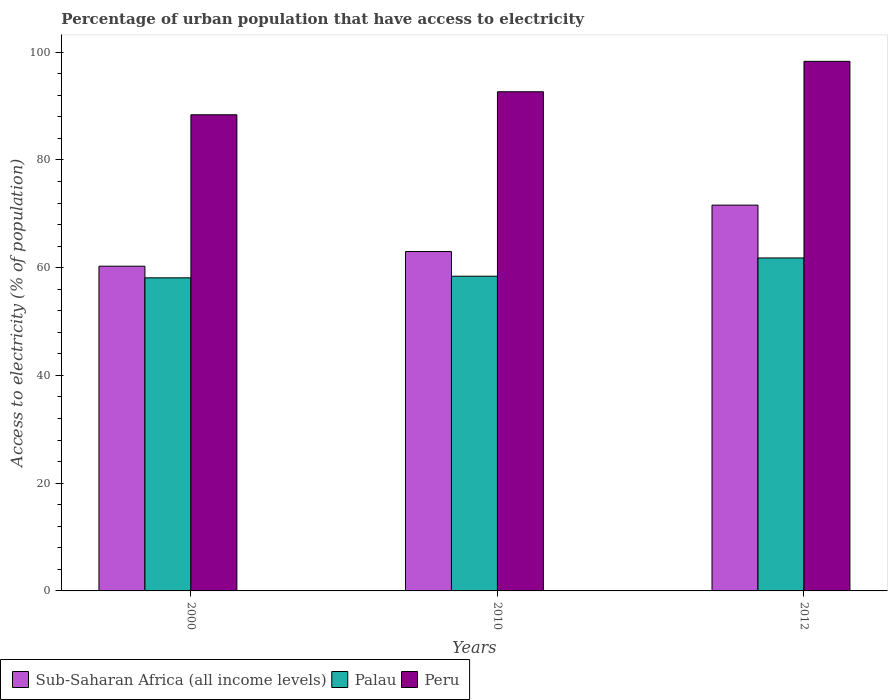How many bars are there on the 1st tick from the left?
Offer a very short reply. 3. In how many cases, is the number of bars for a given year not equal to the number of legend labels?
Provide a succinct answer. 0. What is the percentage of urban population that have access to electricity in Sub-Saharan Africa (all income levels) in 2000?
Offer a very short reply. 60.28. Across all years, what is the maximum percentage of urban population that have access to electricity in Sub-Saharan Africa (all income levels)?
Your response must be concise. 71.61. Across all years, what is the minimum percentage of urban population that have access to electricity in Peru?
Your response must be concise. 88.39. In which year was the percentage of urban population that have access to electricity in Palau maximum?
Give a very brief answer. 2012. What is the total percentage of urban population that have access to electricity in Peru in the graph?
Provide a succinct answer. 279.34. What is the difference between the percentage of urban population that have access to electricity in Peru in 2000 and that in 2012?
Provide a short and direct response. -9.91. What is the difference between the percentage of urban population that have access to electricity in Palau in 2000 and the percentage of urban population that have access to electricity in Peru in 2012?
Provide a short and direct response. -40.18. What is the average percentage of urban population that have access to electricity in Peru per year?
Ensure brevity in your answer.  93.11. In the year 2010, what is the difference between the percentage of urban population that have access to electricity in Palau and percentage of urban population that have access to electricity in Sub-Saharan Africa (all income levels)?
Make the answer very short. -4.58. What is the ratio of the percentage of urban population that have access to electricity in Peru in 2000 to that in 2010?
Make the answer very short. 0.95. Is the percentage of urban population that have access to electricity in Palau in 2000 less than that in 2010?
Make the answer very short. Yes. Is the difference between the percentage of urban population that have access to electricity in Palau in 2000 and 2010 greater than the difference between the percentage of urban population that have access to electricity in Sub-Saharan Africa (all income levels) in 2000 and 2010?
Offer a very short reply. Yes. What is the difference between the highest and the second highest percentage of urban population that have access to electricity in Sub-Saharan Africa (all income levels)?
Provide a short and direct response. 8.62. What is the difference between the highest and the lowest percentage of urban population that have access to electricity in Sub-Saharan Africa (all income levels)?
Your response must be concise. 11.33. What does the 1st bar from the left in 2012 represents?
Your response must be concise. Sub-Saharan Africa (all income levels). What does the 2nd bar from the right in 2000 represents?
Give a very brief answer. Palau. How many bars are there?
Keep it short and to the point. 9. How many years are there in the graph?
Your response must be concise. 3. What is the difference between two consecutive major ticks on the Y-axis?
Offer a terse response. 20. Are the values on the major ticks of Y-axis written in scientific E-notation?
Your answer should be very brief. No. Does the graph contain any zero values?
Your answer should be compact. No. How are the legend labels stacked?
Offer a terse response. Horizontal. What is the title of the graph?
Give a very brief answer. Percentage of urban population that have access to electricity. Does "Uzbekistan" appear as one of the legend labels in the graph?
Provide a short and direct response. No. What is the label or title of the X-axis?
Provide a succinct answer. Years. What is the label or title of the Y-axis?
Your response must be concise. Access to electricity (% of population). What is the Access to electricity (% of population) in Sub-Saharan Africa (all income levels) in 2000?
Provide a short and direct response. 60.28. What is the Access to electricity (% of population) of Palau in 2000?
Your response must be concise. 58.12. What is the Access to electricity (% of population) in Peru in 2000?
Offer a very short reply. 88.39. What is the Access to electricity (% of population) in Sub-Saharan Africa (all income levels) in 2010?
Your answer should be compact. 62.99. What is the Access to electricity (% of population) in Palau in 2010?
Your response must be concise. 58.41. What is the Access to electricity (% of population) in Peru in 2010?
Provide a short and direct response. 92.66. What is the Access to electricity (% of population) of Sub-Saharan Africa (all income levels) in 2012?
Offer a very short reply. 71.61. What is the Access to electricity (% of population) in Palau in 2012?
Provide a succinct answer. 61.8. What is the Access to electricity (% of population) in Peru in 2012?
Your response must be concise. 98.3. Across all years, what is the maximum Access to electricity (% of population) in Sub-Saharan Africa (all income levels)?
Your answer should be very brief. 71.61. Across all years, what is the maximum Access to electricity (% of population) in Palau?
Keep it short and to the point. 61.8. Across all years, what is the maximum Access to electricity (% of population) in Peru?
Your answer should be compact. 98.3. Across all years, what is the minimum Access to electricity (% of population) of Sub-Saharan Africa (all income levels)?
Provide a succinct answer. 60.28. Across all years, what is the minimum Access to electricity (% of population) in Palau?
Keep it short and to the point. 58.12. Across all years, what is the minimum Access to electricity (% of population) of Peru?
Offer a very short reply. 88.39. What is the total Access to electricity (% of population) in Sub-Saharan Africa (all income levels) in the graph?
Your answer should be very brief. 194.88. What is the total Access to electricity (% of population) of Palau in the graph?
Make the answer very short. 178.33. What is the total Access to electricity (% of population) of Peru in the graph?
Make the answer very short. 279.34. What is the difference between the Access to electricity (% of population) in Sub-Saharan Africa (all income levels) in 2000 and that in 2010?
Keep it short and to the point. -2.72. What is the difference between the Access to electricity (% of population) in Palau in 2000 and that in 2010?
Offer a terse response. -0.3. What is the difference between the Access to electricity (% of population) in Peru in 2000 and that in 2010?
Give a very brief answer. -4.27. What is the difference between the Access to electricity (% of population) in Sub-Saharan Africa (all income levels) in 2000 and that in 2012?
Keep it short and to the point. -11.33. What is the difference between the Access to electricity (% of population) of Palau in 2000 and that in 2012?
Offer a very short reply. -3.69. What is the difference between the Access to electricity (% of population) of Peru in 2000 and that in 2012?
Give a very brief answer. -9.91. What is the difference between the Access to electricity (% of population) in Sub-Saharan Africa (all income levels) in 2010 and that in 2012?
Your answer should be compact. -8.62. What is the difference between the Access to electricity (% of population) in Palau in 2010 and that in 2012?
Give a very brief answer. -3.39. What is the difference between the Access to electricity (% of population) in Peru in 2010 and that in 2012?
Your answer should be very brief. -5.64. What is the difference between the Access to electricity (% of population) in Sub-Saharan Africa (all income levels) in 2000 and the Access to electricity (% of population) in Palau in 2010?
Provide a short and direct response. 1.86. What is the difference between the Access to electricity (% of population) in Sub-Saharan Africa (all income levels) in 2000 and the Access to electricity (% of population) in Peru in 2010?
Offer a terse response. -32.38. What is the difference between the Access to electricity (% of population) in Palau in 2000 and the Access to electricity (% of population) in Peru in 2010?
Give a very brief answer. -34.54. What is the difference between the Access to electricity (% of population) of Sub-Saharan Africa (all income levels) in 2000 and the Access to electricity (% of population) of Palau in 2012?
Provide a short and direct response. -1.53. What is the difference between the Access to electricity (% of population) of Sub-Saharan Africa (all income levels) in 2000 and the Access to electricity (% of population) of Peru in 2012?
Provide a short and direct response. -38.02. What is the difference between the Access to electricity (% of population) in Palau in 2000 and the Access to electricity (% of population) in Peru in 2012?
Give a very brief answer. -40.18. What is the difference between the Access to electricity (% of population) in Sub-Saharan Africa (all income levels) in 2010 and the Access to electricity (% of population) in Palau in 2012?
Keep it short and to the point. 1.19. What is the difference between the Access to electricity (% of population) in Sub-Saharan Africa (all income levels) in 2010 and the Access to electricity (% of population) in Peru in 2012?
Offer a very short reply. -35.31. What is the difference between the Access to electricity (% of population) of Palau in 2010 and the Access to electricity (% of population) of Peru in 2012?
Provide a short and direct response. -39.89. What is the average Access to electricity (% of population) of Sub-Saharan Africa (all income levels) per year?
Provide a short and direct response. 64.96. What is the average Access to electricity (% of population) of Palau per year?
Make the answer very short. 59.44. What is the average Access to electricity (% of population) of Peru per year?
Keep it short and to the point. 93.11. In the year 2000, what is the difference between the Access to electricity (% of population) in Sub-Saharan Africa (all income levels) and Access to electricity (% of population) in Palau?
Provide a succinct answer. 2.16. In the year 2000, what is the difference between the Access to electricity (% of population) of Sub-Saharan Africa (all income levels) and Access to electricity (% of population) of Peru?
Your answer should be very brief. -28.11. In the year 2000, what is the difference between the Access to electricity (% of population) of Palau and Access to electricity (% of population) of Peru?
Offer a very short reply. -30.27. In the year 2010, what is the difference between the Access to electricity (% of population) in Sub-Saharan Africa (all income levels) and Access to electricity (% of population) in Palau?
Offer a terse response. 4.58. In the year 2010, what is the difference between the Access to electricity (% of population) of Sub-Saharan Africa (all income levels) and Access to electricity (% of population) of Peru?
Offer a terse response. -29.66. In the year 2010, what is the difference between the Access to electricity (% of population) in Palau and Access to electricity (% of population) in Peru?
Your answer should be compact. -34.24. In the year 2012, what is the difference between the Access to electricity (% of population) in Sub-Saharan Africa (all income levels) and Access to electricity (% of population) in Palau?
Offer a terse response. 9.81. In the year 2012, what is the difference between the Access to electricity (% of population) of Sub-Saharan Africa (all income levels) and Access to electricity (% of population) of Peru?
Provide a short and direct response. -26.69. In the year 2012, what is the difference between the Access to electricity (% of population) in Palau and Access to electricity (% of population) in Peru?
Keep it short and to the point. -36.5. What is the ratio of the Access to electricity (% of population) in Sub-Saharan Africa (all income levels) in 2000 to that in 2010?
Ensure brevity in your answer.  0.96. What is the ratio of the Access to electricity (% of population) in Peru in 2000 to that in 2010?
Your response must be concise. 0.95. What is the ratio of the Access to electricity (% of population) in Sub-Saharan Africa (all income levels) in 2000 to that in 2012?
Your answer should be compact. 0.84. What is the ratio of the Access to electricity (% of population) of Palau in 2000 to that in 2012?
Provide a succinct answer. 0.94. What is the ratio of the Access to electricity (% of population) in Peru in 2000 to that in 2012?
Offer a terse response. 0.9. What is the ratio of the Access to electricity (% of population) in Sub-Saharan Africa (all income levels) in 2010 to that in 2012?
Provide a short and direct response. 0.88. What is the ratio of the Access to electricity (% of population) of Palau in 2010 to that in 2012?
Your response must be concise. 0.95. What is the ratio of the Access to electricity (% of population) of Peru in 2010 to that in 2012?
Offer a terse response. 0.94. What is the difference between the highest and the second highest Access to electricity (% of population) of Sub-Saharan Africa (all income levels)?
Your answer should be very brief. 8.62. What is the difference between the highest and the second highest Access to electricity (% of population) in Palau?
Offer a terse response. 3.39. What is the difference between the highest and the second highest Access to electricity (% of population) in Peru?
Your answer should be very brief. 5.64. What is the difference between the highest and the lowest Access to electricity (% of population) of Sub-Saharan Africa (all income levels)?
Your answer should be compact. 11.33. What is the difference between the highest and the lowest Access to electricity (% of population) of Palau?
Your answer should be very brief. 3.69. What is the difference between the highest and the lowest Access to electricity (% of population) in Peru?
Provide a succinct answer. 9.91. 